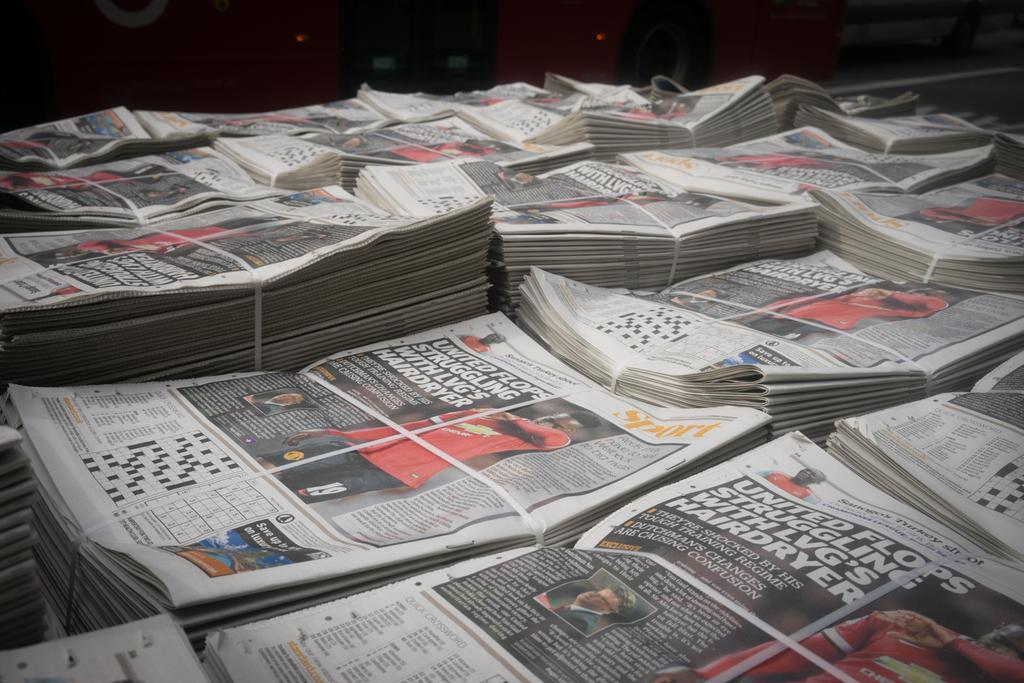<image>
Provide a brief description of the given image. newspaper stacks that say 'united flops' on the covers 